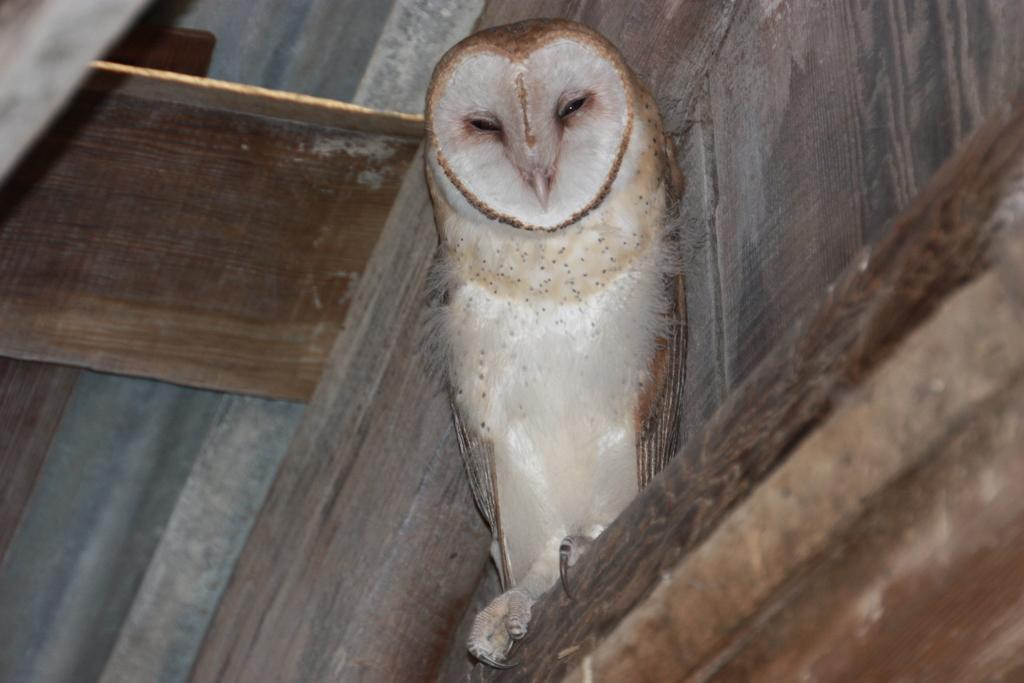What type of animal is in the image? There is an owl in the image. What material are some of the objects made of in the image? There are wooden planks in the image. What type of friction can be observed between the owl and the wooden planks in the image? There is no indication of friction between the owl and the wooden planks in the image, as they are not interacting with each other. 